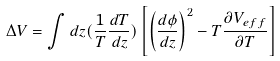<formula> <loc_0><loc_0><loc_500><loc_500>\Delta V = \int d z ( \frac { 1 } { T } \frac { d T } { d z } ) \left [ \left ( \frac { d \phi } { d z } \right ) ^ { 2 } - T \frac { \partial V _ { e f f } } { \partial T } \right ]</formula> 